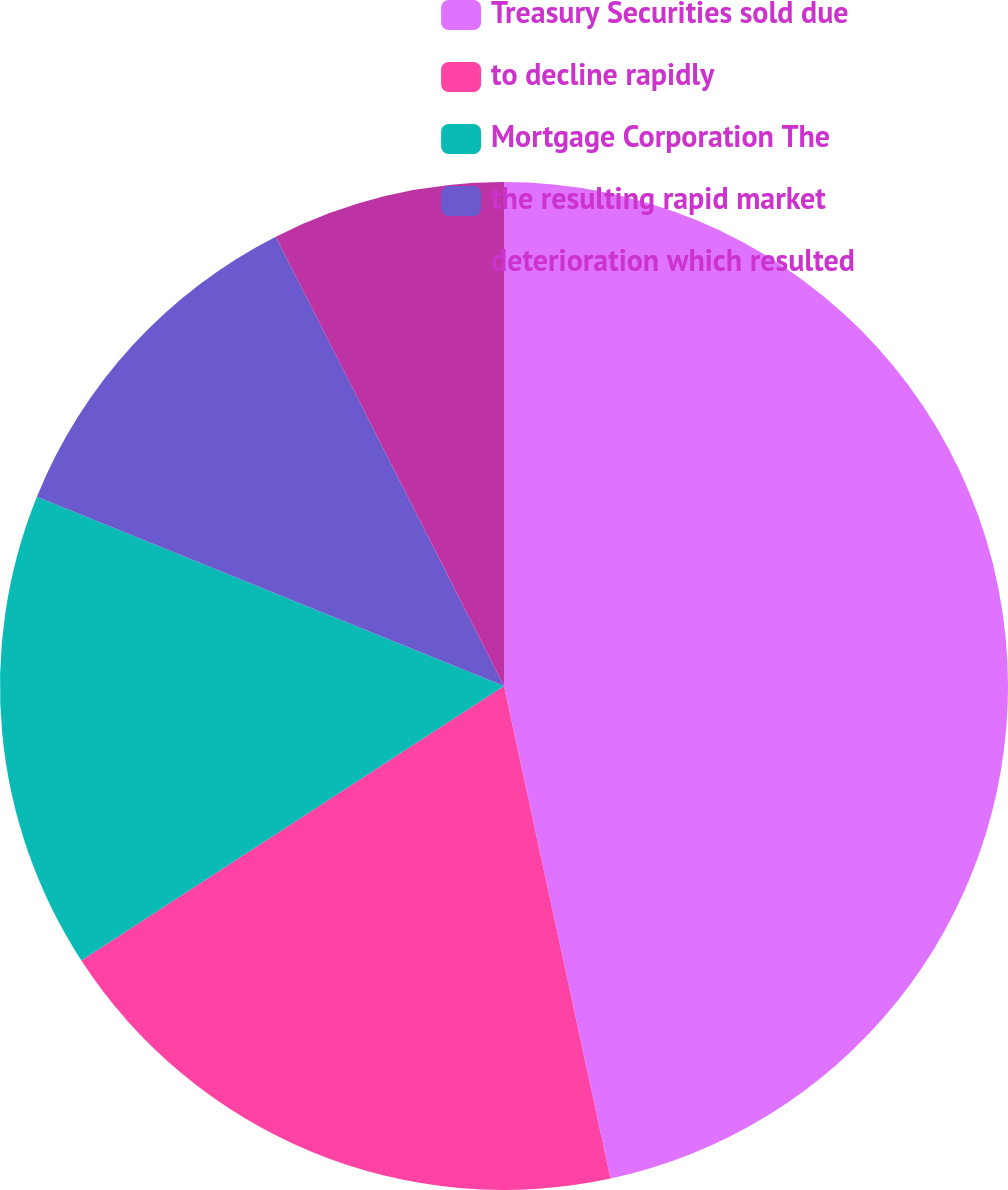<chart> <loc_0><loc_0><loc_500><loc_500><pie_chart><fcel>Treasury Securities sold due<fcel>to decline rapidly<fcel>Mortgage Corporation The<fcel>the resulting rapid market<fcel>deterioration which resulted<nl><fcel>46.61%<fcel>19.22%<fcel>15.3%<fcel>11.39%<fcel>7.48%<nl></chart> 